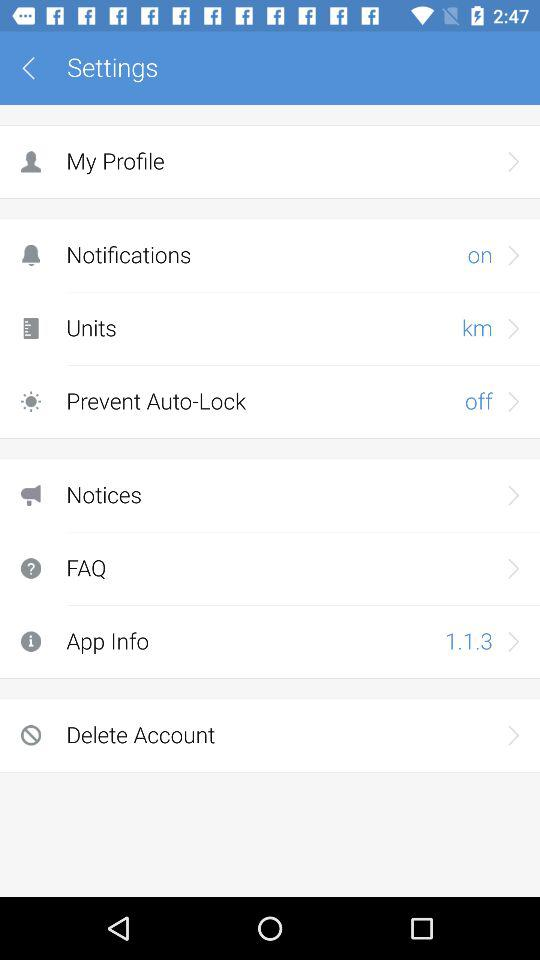What is the app version? The app version is 1.1.3. 